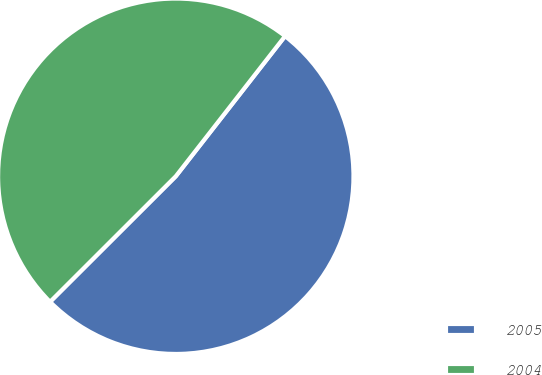<chart> <loc_0><loc_0><loc_500><loc_500><pie_chart><fcel>2005<fcel>2004<nl><fcel>51.97%<fcel>48.03%<nl></chart> 